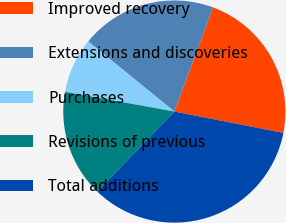<chart> <loc_0><loc_0><loc_500><loc_500><pie_chart><fcel>Improved recovery<fcel>Extensions and discoveries<fcel>Purchases<fcel>Revisions of previous<fcel>Total additions<nl><fcel>22.41%<fcel>19.8%<fcel>8.02%<fcel>15.62%<fcel>34.14%<nl></chart> 